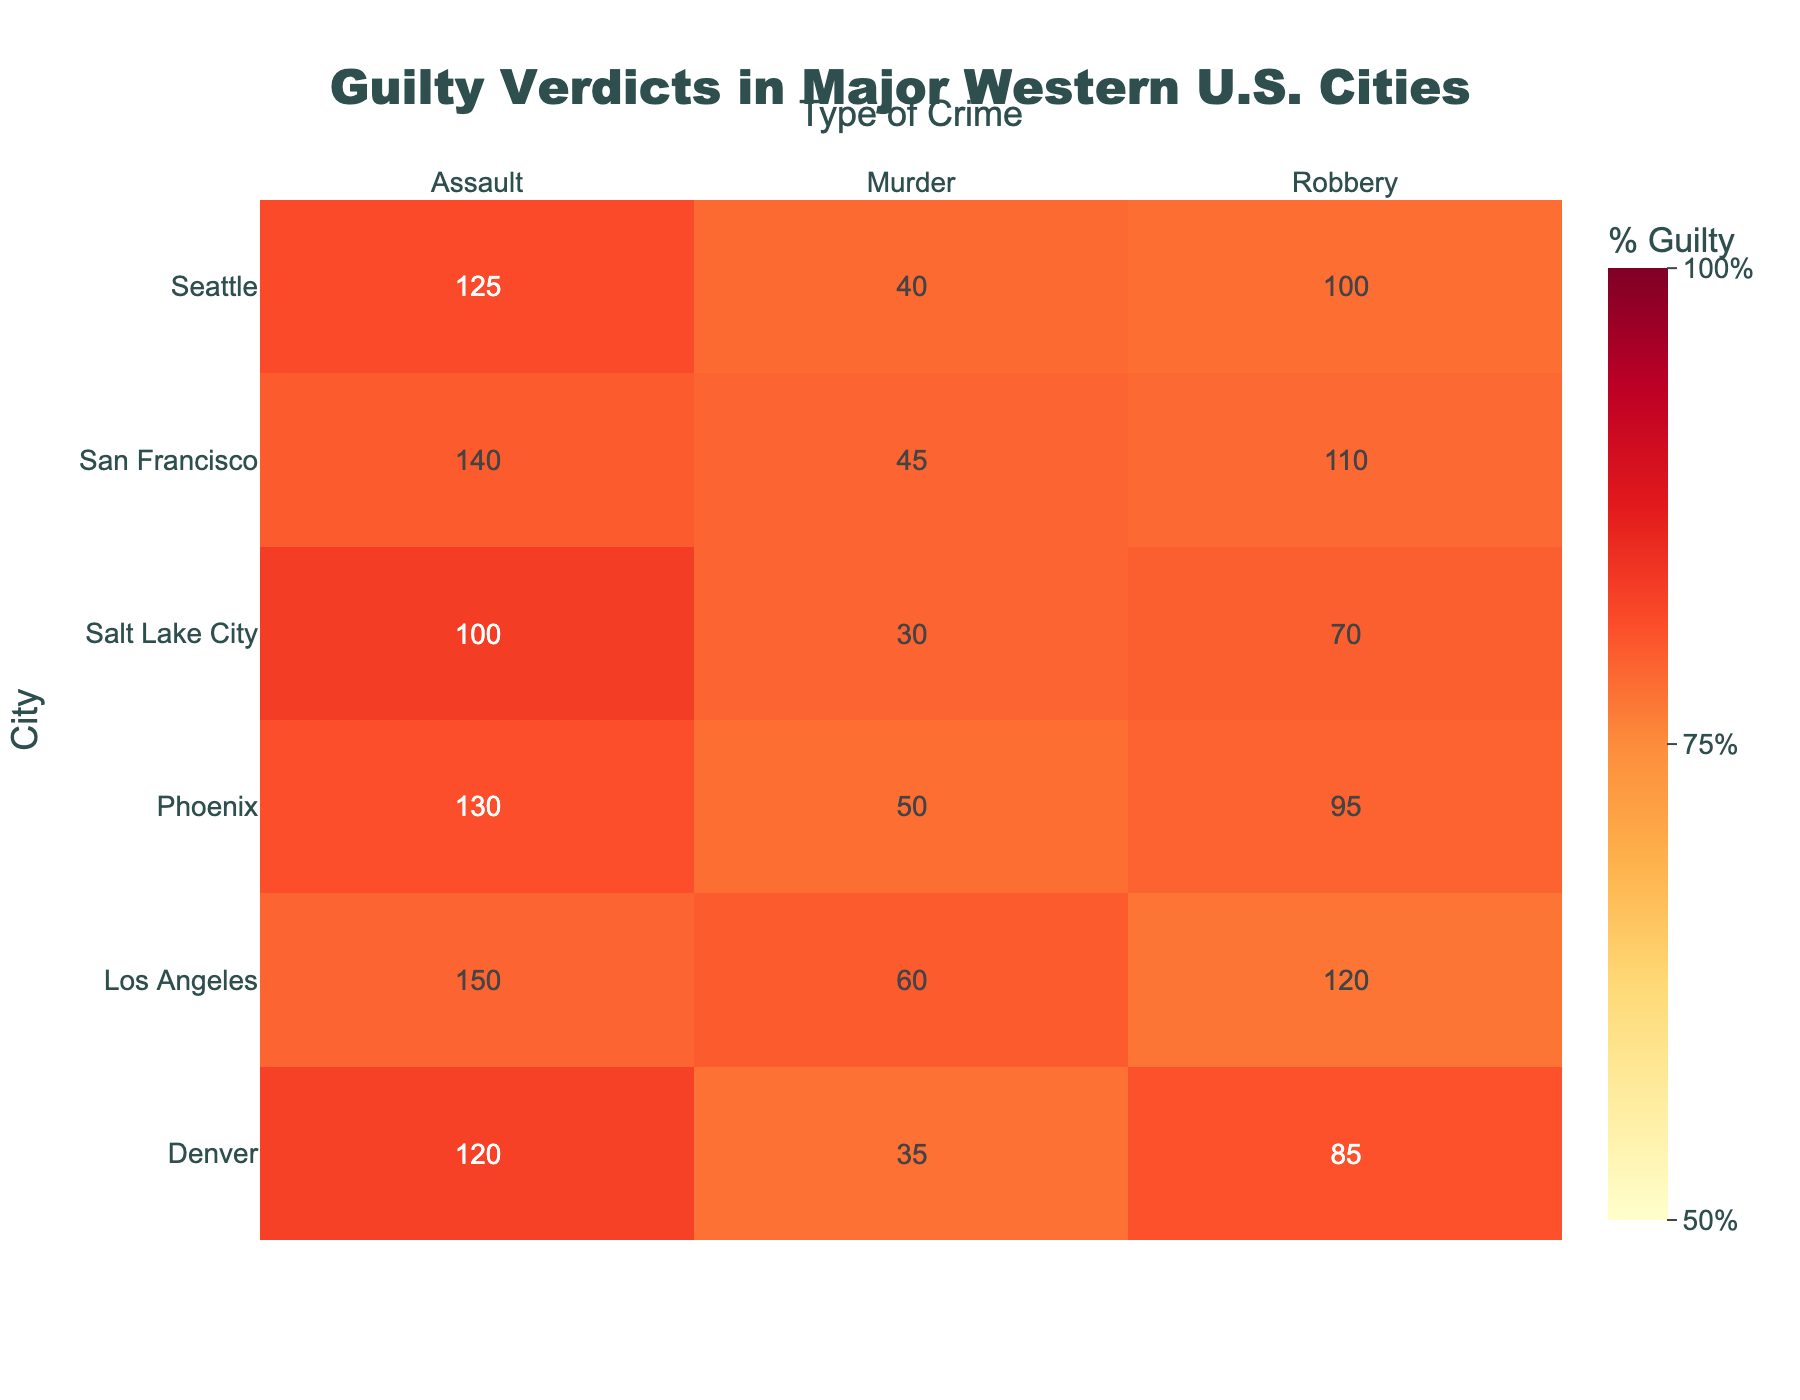What is the title of the heatmap? The title can be found at the top center of the heatmap. It is "Guilty Verdicts in Major Western U.S. Cities."
Answer: Guilty Verdicts in Major Western U.S. Cities What percentage of guilty verdicts for assault does Los Angeles have? Locate Los Angeles along the y-axis and Assault along the x-axis. Then, find the intersecting cell which contains the percentage.
Answer: Approximately 79% Which city recorded a higher percentage of guilty verdicts for robbery, San Francisco or Denver? Compare the percentage values in the cells where San Francisco and Denver intersect with the Robbery column. San Francisco has a higher percentage (approximately 79%) compared to Denver (approximately 81%).
Answer: Denver How many guilty verdicts for murder did Phoenix record? Locate Phoenix along the y-axis and Murder along the x-axis. The text within the intersecting cell for the "Guilty" values shows 50.
Answer: 50 Which city had the lowest percentage of guilty verdicts for murder? Compare the percentage of guilty verdicts for Murder across all cities. Salt Lake City has the lowest percentage, which is approximately 79%.
Answer: Salt Lake City In terms of percentage, which type of crime had the highest guilty verdict rate in Seattle? Locate Seattle along the y-axis, and then compare the percentages for Robbery, Murder, and Assault. Assault has the highest percentage of guilty verdicts of approximately 81%.
Answer: Assault Calculate and compare the total number of guilty verdicts for all crimes in Los Angeles and Seattle. Which city had more? Sum the number of guilty verdicts for Robbery, Murder, and Assault for both cities. Los Angeles: 120 (Robbery) + 60 (Murder) + 150 (Assault) = 330, Seattle: 100 (Robbery) + 40 (Murder) + 125 (Assault) = 265. Los Angeles had more guilty verdicts.
Answer: Los Angeles Across all cities, which type of crime had the most consistent (smallest range) percentage of guilty verdicts? Calculate the range of percentages for Robbery, Murder, and Assault across all cities. Robbery: 63% - 87% = 24%, Murder: 73% - 79% = 6%, Assault: 79% - 86% = 7%. Murder had the smallest range of percentages.
Answer: Murder 